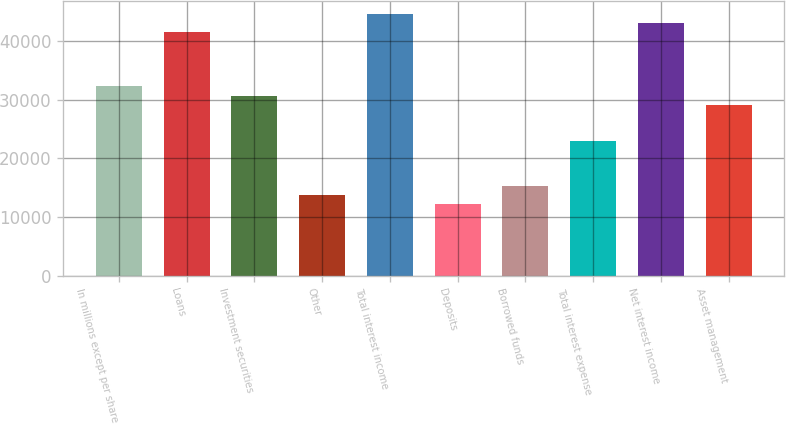<chart> <loc_0><loc_0><loc_500><loc_500><bar_chart><fcel>In millions except per share<fcel>Loans<fcel>Investment securities<fcel>Other<fcel>Total interest income<fcel>Deposits<fcel>Borrowed funds<fcel>Total interest expense<fcel>Net interest income<fcel>Asset management<nl><fcel>32283.1<fcel>41505.7<fcel>30746<fcel>13837.9<fcel>44579.9<fcel>12300.8<fcel>15375<fcel>23060.5<fcel>43042.8<fcel>29208.9<nl></chart> 